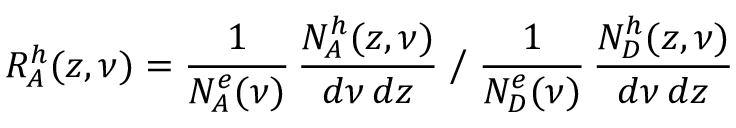<formula> <loc_0><loc_0><loc_500><loc_500>R _ { A } ^ { h } ( z , \nu ) = \frac { 1 } { N _ { A } ^ { e } ( \nu ) } \, \frac { N _ { A } ^ { h } ( z , \nu ) } { d \nu \, d z } \Big / \frac { 1 } { N _ { D } ^ { e } ( \nu ) } \, \frac { N _ { D } ^ { h } ( z , \nu ) } { d \nu \, d z }</formula> 